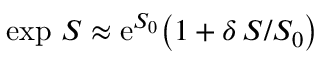Convert formula to latex. <formula><loc_0><loc_0><loc_500><loc_500>\exp \, S \approx e ^ { S _ { 0 } } \left ( 1 + \delta \, S / S _ { 0 } \right )</formula> 